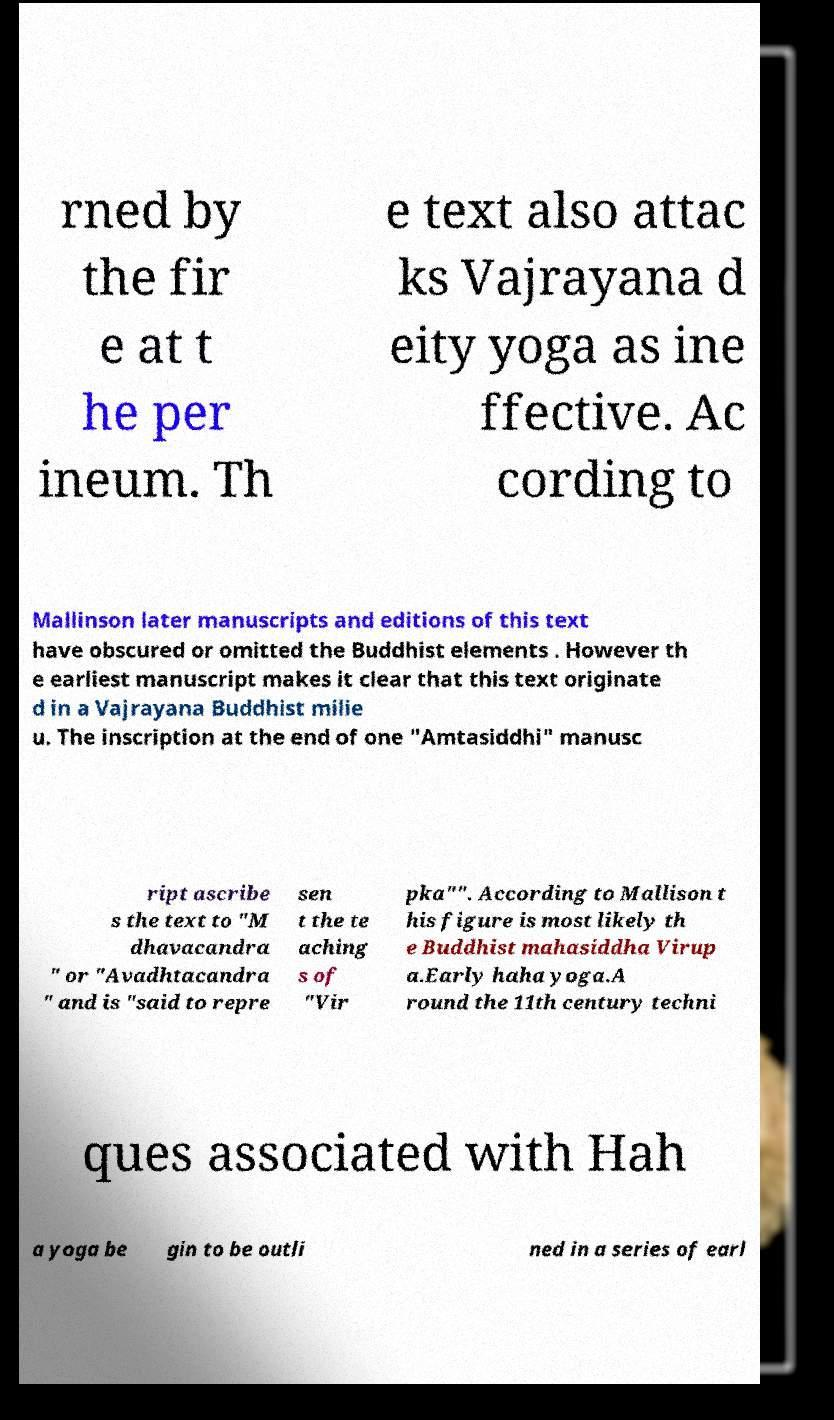What messages or text are displayed in this image? I need them in a readable, typed format. rned by the fir e at t he per ineum. Th e text also attac ks Vajrayana d eity yoga as ine ffective. Ac cording to Mallinson later manuscripts and editions of this text have obscured or omitted the Buddhist elements . However th e earliest manuscript makes it clear that this text originate d in a Vajrayana Buddhist milie u. The inscription at the end of one "Amtasiddhi" manusc ript ascribe s the text to "M dhavacandra " or "Avadhtacandra " and is "said to repre sen t the te aching s of "Vir pka"". According to Mallison t his figure is most likely th e Buddhist mahasiddha Virup a.Early haha yoga.A round the 11th century techni ques associated with Hah a yoga be gin to be outli ned in a series of earl 